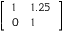Convert formula to latex. <formula><loc_0><loc_0><loc_500><loc_500>\left [ \begin{array} { l l } { 1 } & { 1 . 2 5 } \\ { 0 } & { 1 } \end{array} \right ]</formula> 